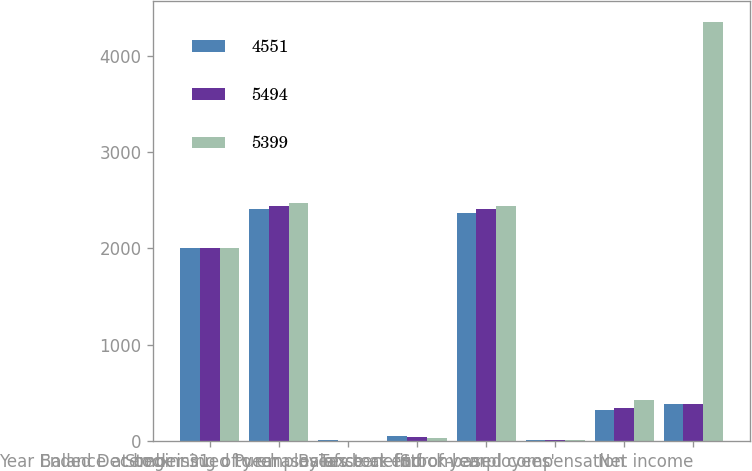Convert chart. <chart><loc_0><loc_0><loc_500><loc_500><stacked_bar_chart><ecel><fcel>Year Ended December 31<fcel>Balance at beginning of year<fcel>Stock issued to employees<fcel>Purchases of stock for<fcel>Balance at end of year<fcel>Tax benefit from employees'<fcel>Stock-based compensation<fcel>Net income<nl><fcel>4551<fcel>2005<fcel>2409<fcel>7<fcel>47<fcel>2369<fcel>11<fcel>324<fcel>383.5<nl><fcel>5494<fcel>2004<fcel>2442<fcel>5<fcel>38<fcel>2409<fcel>13<fcel>345<fcel>383.5<nl><fcel>5399<fcel>2003<fcel>2471<fcel>4<fcel>33<fcel>2442<fcel>11<fcel>422<fcel>4347<nl></chart> 